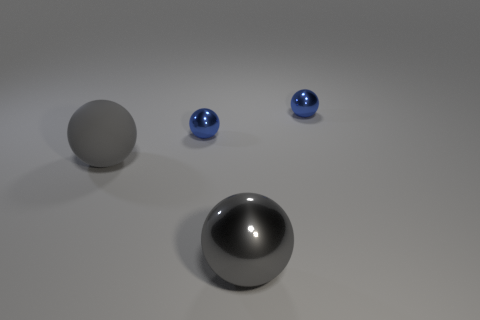Subtract all gray rubber balls. How many balls are left? 3 Add 1 balls. How many objects exist? 5 Subtract all tiny cyan matte objects. Subtract all gray rubber spheres. How many objects are left? 3 Add 3 small things. How many small things are left? 5 Add 1 tiny purple blocks. How many tiny purple blocks exist? 1 Subtract all blue spheres. How many spheres are left? 2 Subtract 2 blue spheres. How many objects are left? 2 Subtract 1 spheres. How many spheres are left? 3 Subtract all purple balls. Subtract all gray cylinders. How many balls are left? 4 Subtract all red cylinders. How many yellow spheres are left? 0 